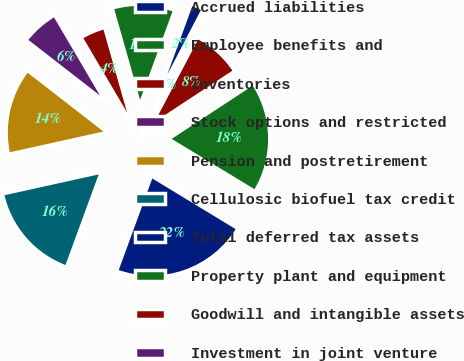<chart> <loc_0><loc_0><loc_500><loc_500><pie_chart><fcel>Accrued liabilities<fcel>Employee benefits and<fcel>Inventories<fcel>Stock options and restricted<fcel>Pension and postretirement<fcel>Cellulosic biofuel tax credit<fcel>Total deferred tax assets<fcel>Property plant and equipment<fcel>Goodwill and intangible assets<fcel>Investment in joint venture<nl><fcel>2.06%<fcel>10.0%<fcel>4.05%<fcel>6.03%<fcel>13.97%<fcel>15.95%<fcel>21.9%<fcel>17.94%<fcel>8.02%<fcel>0.08%<nl></chart> 